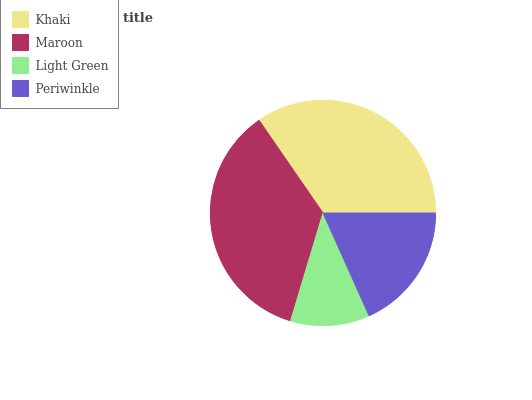Is Light Green the minimum?
Answer yes or no. Yes. Is Maroon the maximum?
Answer yes or no. Yes. Is Maroon the minimum?
Answer yes or no. No. Is Light Green the maximum?
Answer yes or no. No. Is Maroon greater than Light Green?
Answer yes or no. Yes. Is Light Green less than Maroon?
Answer yes or no. Yes. Is Light Green greater than Maroon?
Answer yes or no. No. Is Maroon less than Light Green?
Answer yes or no. No. Is Khaki the high median?
Answer yes or no. Yes. Is Periwinkle the low median?
Answer yes or no. Yes. Is Light Green the high median?
Answer yes or no. No. Is Maroon the low median?
Answer yes or no. No. 